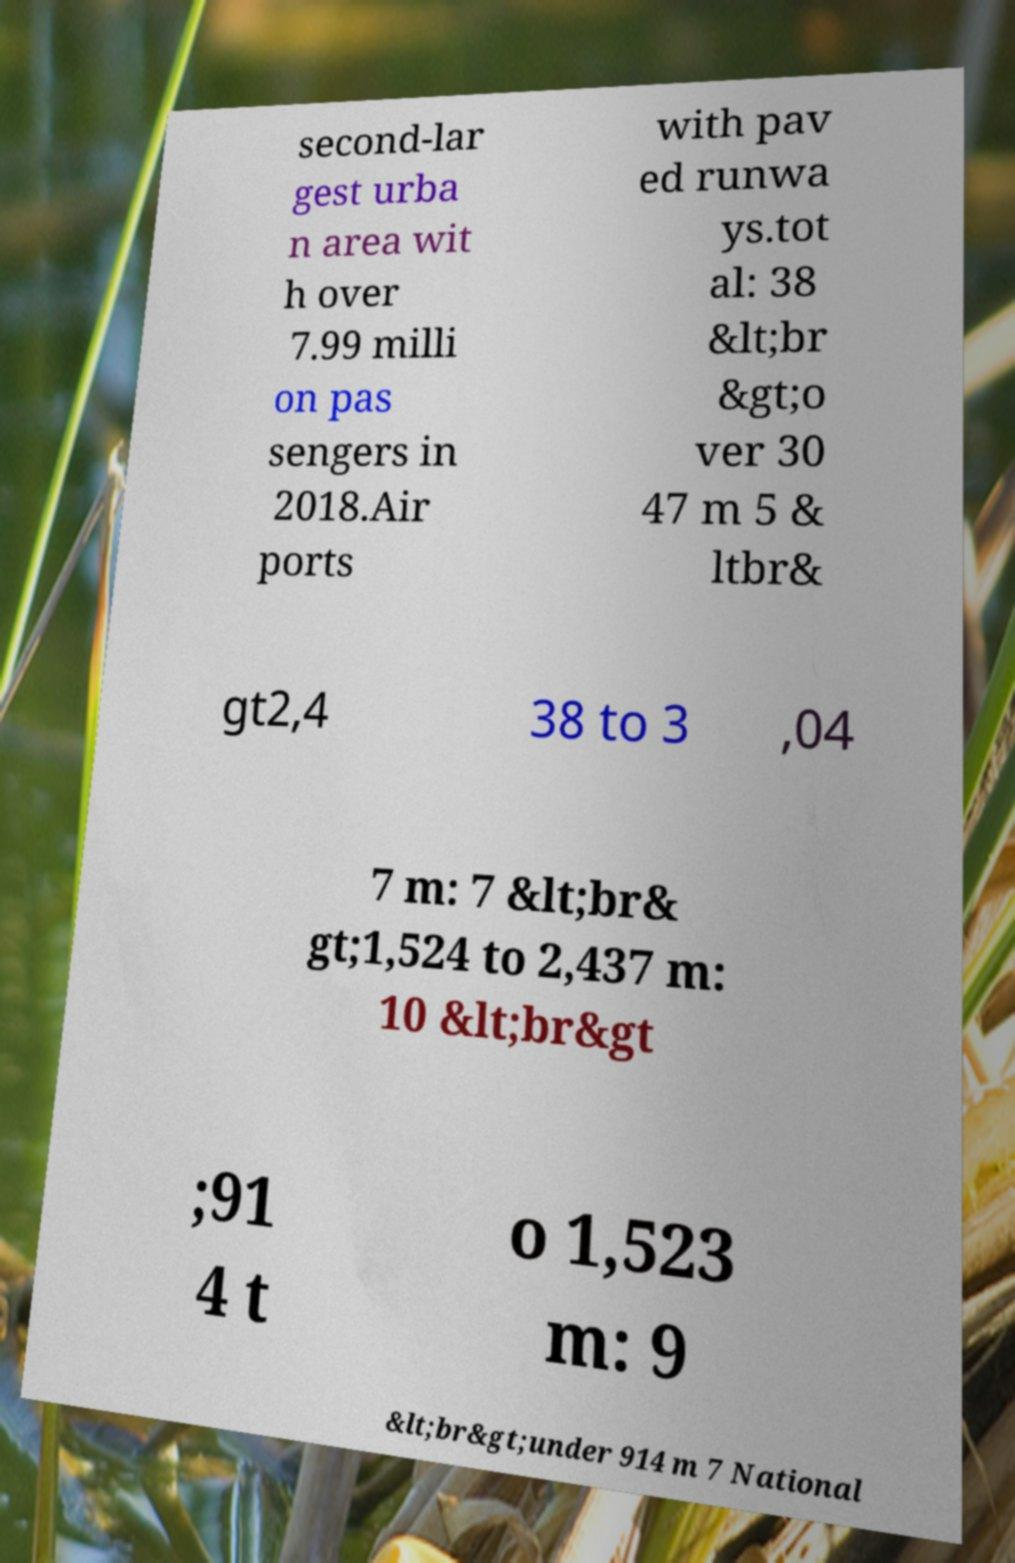Could you assist in decoding the text presented in this image and type it out clearly? second-lar gest urba n area wit h over 7.99 milli on pas sengers in 2018.Air ports with pav ed runwa ys.tot al: 38 &lt;br &gt;o ver 30 47 m 5 & ltbr& gt2,4 38 to 3 ,04 7 m: 7 &lt;br& gt;1,524 to 2,437 m: 10 &lt;br&gt ;91 4 t o 1,523 m: 9 &lt;br&gt;under 914 m 7 National 